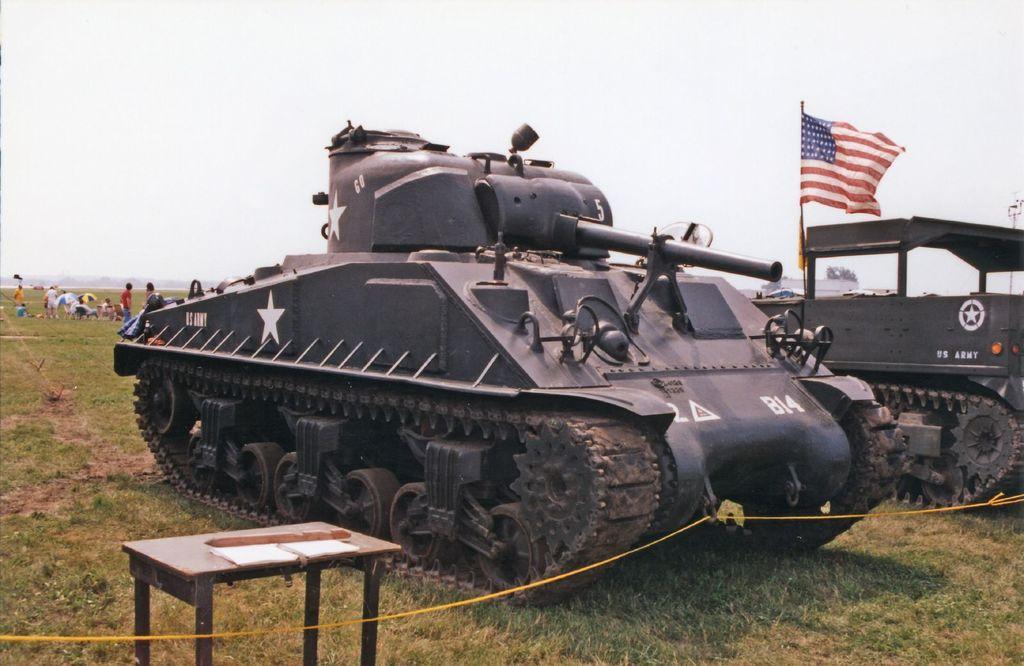Describe this image in one or two sentences. In the center we can see crane machine,on the left we can see table. On the right we can see another crane machine and flag. Coming to background we can see sky with clouds,grass and few persons were standing. 